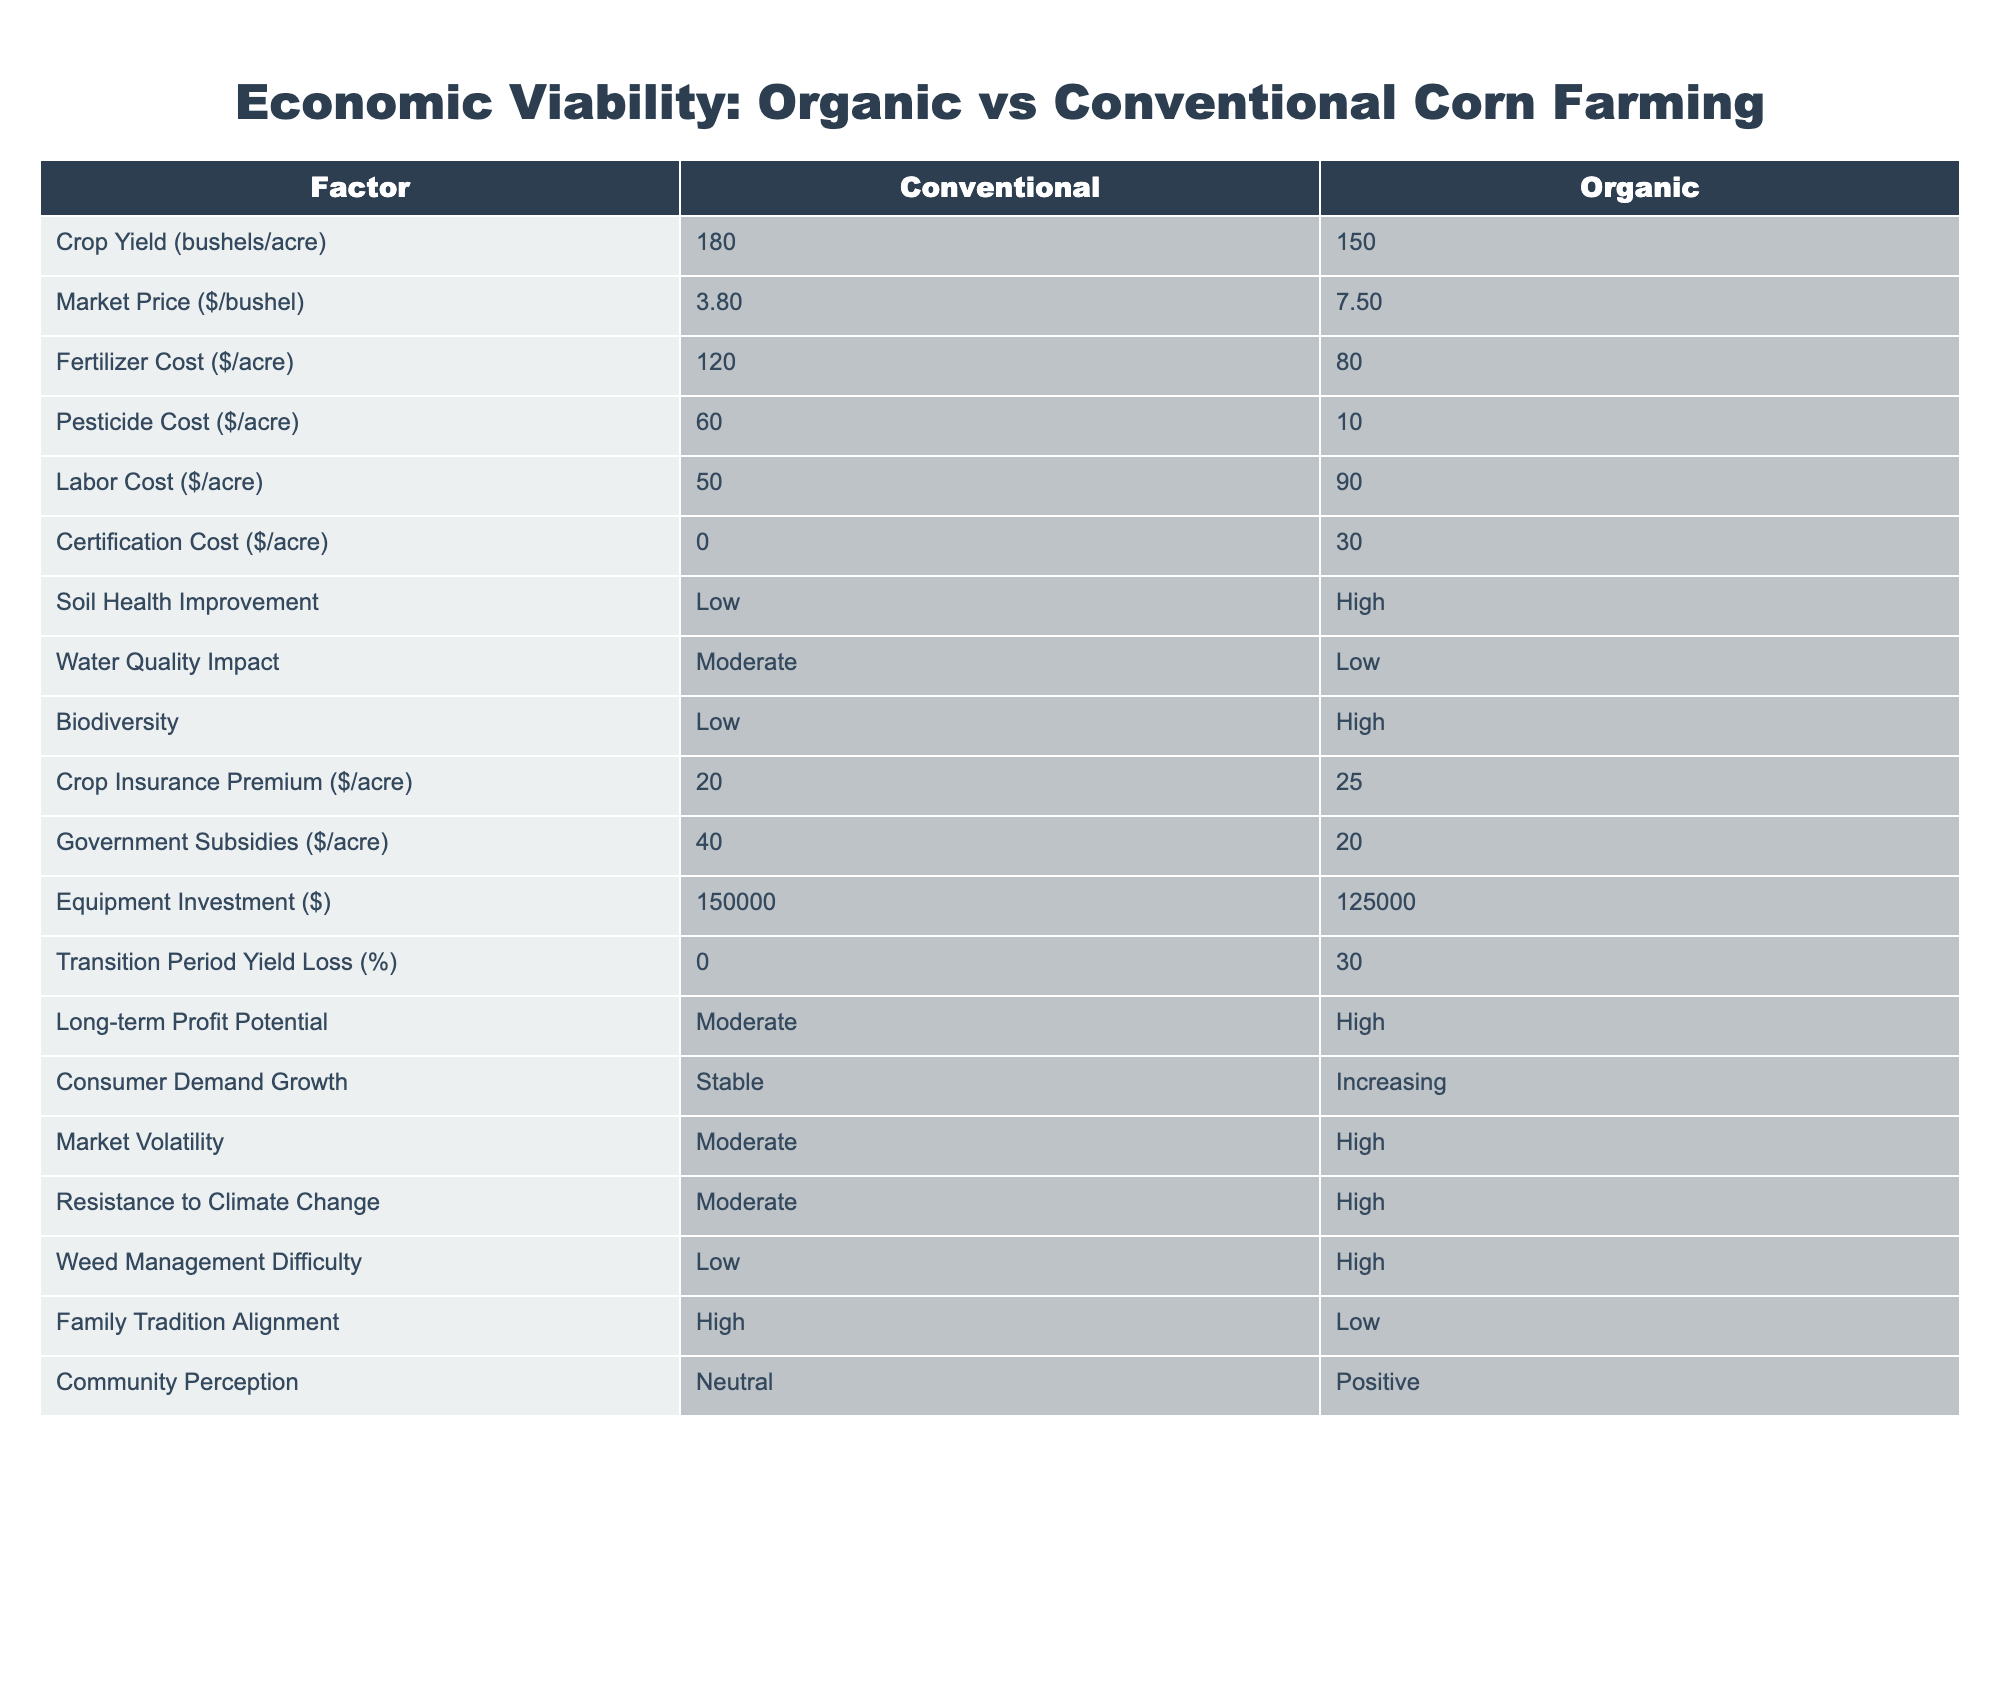What is the crop yield per acre for conventional farming? The table indicates that the crop yield for conventional farming is specified as 180 bushels per acre.
Answer: 180 bushels/acre What is the market price per bushel for organic corn? According to the table, the market price for organic corn is listed as $7.50 per bushel.
Answer: $7.50 What is the total cost for fertilizer and pesticide per acre in conventional farming? For conventional farming, the fertilizer cost is $120 per acre, and the pesticide cost is $60 per acre. Adding these gives a total of 120 + 60 = $180 per acre.
Answer: $180 Is the soil health improvement higher in organic farming compared to conventional farming? The table shows that soil health improvement is high for organic farming and low for conventional farming. Therefore, the statement is true.
Answer: Yes What are the labor costs for organic farming, and how do they compare to conventional farming? The table states that organic farming labor cost is $90 per acre while conventional farming is $50 per acre. This indicates that organic farming has higher labor costs by 90 - 50 = $40.
Answer: $90, higher by $40 Is the government subsidy greater for conventional or organic farming? The table lists government subsidies as $40 per acre for conventional farming and $20 per acre for organic farming. This shows that conventional farming has greater subsidies.
Answer: Conventional farming What is the average yield loss during the transition period for organic farming? The table specifies a yield loss of 30% during the transition period for organic farming. Therefore, the average yield loss is 30%.
Answer: 30% Does organic farming have lower impacts on biodiversity compared to conventional farming? The table indicates that biodiversity is low for conventional farming and high for organic farming, making the statement false.
Answer: No If a farmer invests in organic farming, how does the initial equipment investment compare to conventional farming? According to the table, the equipment investment is $125,000 for organic farming and $150,000 for conventional farming, indicating that organic farming requires $25,000 less to start.
Answer: $125,000, $25,000 less 